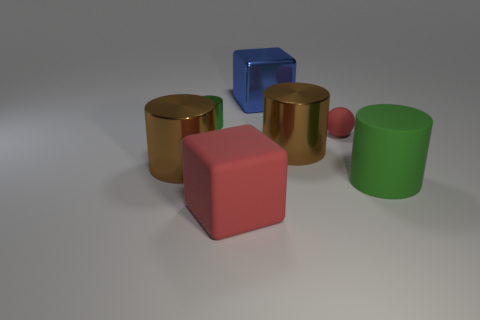Is the color of the tiny matte thing the same as the rubber block?
Your answer should be compact. Yes. What is the shape of the tiny green thing that is made of the same material as the large blue cube?
Your response must be concise. Cylinder. Is there anything else of the same color as the small metallic object?
Your answer should be very brief. Yes. What material is the red thing that is the same shape as the big blue metallic object?
Make the answer very short. Rubber. What number of other objects are there of the same size as the red rubber block?
Your response must be concise. 4. What material is the tiny green thing?
Your response must be concise. Metal. Are there more green objects on the right side of the big red object than tiny brown metallic things?
Your answer should be very brief. Yes. Is there a tiny brown cube?
Keep it short and to the point. No. What number of other objects are there of the same shape as the blue metal thing?
Offer a very short reply. 1. Does the cylinder right of the tiny matte ball have the same color as the tiny thing that is to the left of the matte cube?
Make the answer very short. Yes. 